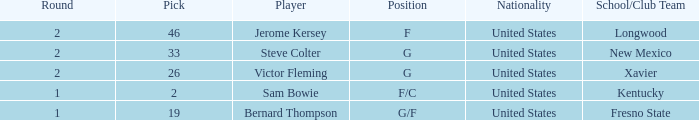What is Player, when Round is "2", and when School/Club Team is "Xavier"? Victor Fleming. 